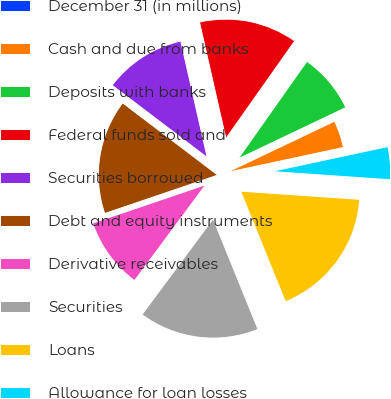<chart> <loc_0><loc_0><loc_500><loc_500><pie_chart><fcel>December 31 (in millions)<fcel>Cash and due from banks<fcel>Deposits with banks<fcel>Federal funds sold and<fcel>Securities borrowed<fcel>Debt and equity instruments<fcel>Derivative receivables<fcel>Securities<fcel>Loans<fcel>Allowance for loan losses<nl><fcel>0.01%<fcel>3.71%<fcel>8.15%<fcel>13.33%<fcel>11.11%<fcel>15.55%<fcel>9.63%<fcel>16.29%<fcel>17.77%<fcel>4.45%<nl></chart> 